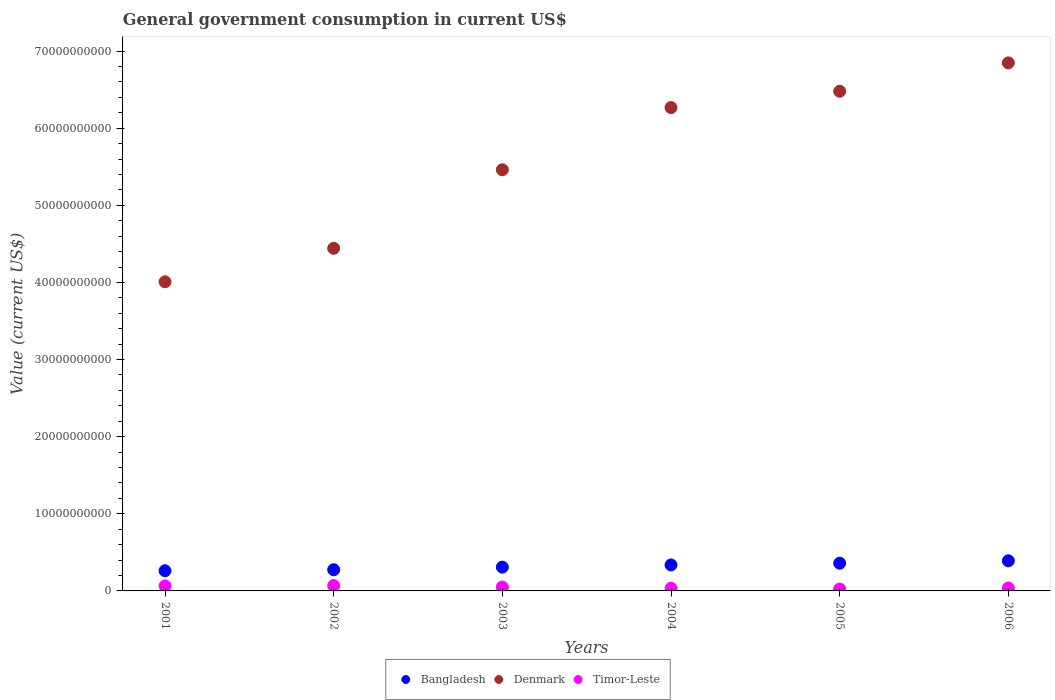How many different coloured dotlines are there?
Your response must be concise. 3. Is the number of dotlines equal to the number of legend labels?
Your response must be concise. Yes. What is the government conusmption in Bangladesh in 2003?
Give a very brief answer. 3.09e+09. Across all years, what is the maximum government conusmption in Denmark?
Your answer should be compact. 6.85e+1. Across all years, what is the minimum government conusmption in Denmark?
Your answer should be compact. 4.01e+1. In which year was the government conusmption in Bangladesh minimum?
Offer a terse response. 2001. What is the total government conusmption in Bangladesh in the graph?
Your answer should be very brief. 1.93e+1. What is the difference between the government conusmption in Timor-Leste in 2001 and that in 2004?
Provide a short and direct response. 3.05e+08. What is the difference between the government conusmption in Bangladesh in 2004 and the government conusmption in Denmark in 2002?
Provide a succinct answer. -4.11e+1. What is the average government conusmption in Bangladesh per year?
Provide a short and direct response. 3.22e+09. In the year 2004, what is the difference between the government conusmption in Bangladesh and government conusmption in Denmark?
Provide a succinct answer. -5.93e+1. What is the ratio of the government conusmption in Bangladesh in 2003 to that in 2004?
Ensure brevity in your answer.  0.92. Is the government conusmption in Bangladesh in 2001 less than that in 2005?
Your answer should be compact. Yes. Is the difference between the government conusmption in Bangladesh in 2002 and 2003 greater than the difference between the government conusmption in Denmark in 2002 and 2003?
Ensure brevity in your answer.  Yes. What is the difference between the highest and the second highest government conusmption in Denmark?
Keep it short and to the point. 3.68e+09. What is the difference between the highest and the lowest government conusmption in Bangladesh?
Offer a very short reply. 1.29e+09. In how many years, is the government conusmption in Denmark greater than the average government conusmption in Denmark taken over all years?
Provide a short and direct response. 3. Is it the case that in every year, the sum of the government conusmption in Timor-Leste and government conusmption in Denmark  is greater than the government conusmption in Bangladesh?
Provide a succinct answer. Yes. Are the values on the major ticks of Y-axis written in scientific E-notation?
Offer a terse response. No. Does the graph contain any zero values?
Provide a short and direct response. No. Does the graph contain grids?
Your answer should be compact. No. What is the title of the graph?
Provide a short and direct response. General government consumption in current US$. What is the label or title of the Y-axis?
Make the answer very short. Value (current US$). What is the Value (current US$) in Bangladesh in 2001?
Provide a succinct answer. 2.62e+09. What is the Value (current US$) in Denmark in 2001?
Provide a succinct answer. 4.01e+1. What is the Value (current US$) of Timor-Leste in 2001?
Offer a terse response. 6.52e+08. What is the Value (current US$) of Bangladesh in 2002?
Give a very brief answer. 2.75e+09. What is the Value (current US$) of Denmark in 2002?
Give a very brief answer. 4.44e+1. What is the Value (current US$) in Timor-Leste in 2002?
Your answer should be very brief. 6.95e+08. What is the Value (current US$) in Bangladesh in 2003?
Offer a terse response. 3.09e+09. What is the Value (current US$) in Denmark in 2003?
Your response must be concise. 5.46e+1. What is the Value (current US$) in Timor-Leste in 2003?
Your answer should be compact. 5.03e+08. What is the Value (current US$) of Bangladesh in 2004?
Offer a very short reply. 3.37e+09. What is the Value (current US$) in Denmark in 2004?
Provide a succinct answer. 6.27e+1. What is the Value (current US$) of Timor-Leste in 2004?
Give a very brief answer. 3.47e+08. What is the Value (current US$) of Bangladesh in 2005?
Provide a short and direct response. 3.60e+09. What is the Value (current US$) in Denmark in 2005?
Your response must be concise. 6.48e+1. What is the Value (current US$) in Timor-Leste in 2005?
Make the answer very short. 2.47e+08. What is the Value (current US$) of Bangladesh in 2006?
Give a very brief answer. 3.91e+09. What is the Value (current US$) in Denmark in 2006?
Offer a very short reply. 6.85e+1. What is the Value (current US$) in Timor-Leste in 2006?
Your response must be concise. 3.78e+08. Across all years, what is the maximum Value (current US$) of Bangladesh?
Provide a succinct answer. 3.91e+09. Across all years, what is the maximum Value (current US$) of Denmark?
Make the answer very short. 6.85e+1. Across all years, what is the maximum Value (current US$) in Timor-Leste?
Your answer should be very brief. 6.95e+08. Across all years, what is the minimum Value (current US$) of Bangladesh?
Keep it short and to the point. 2.62e+09. Across all years, what is the minimum Value (current US$) in Denmark?
Provide a short and direct response. 4.01e+1. Across all years, what is the minimum Value (current US$) in Timor-Leste?
Offer a terse response. 2.47e+08. What is the total Value (current US$) of Bangladesh in the graph?
Offer a very short reply. 1.93e+1. What is the total Value (current US$) in Denmark in the graph?
Give a very brief answer. 3.35e+11. What is the total Value (current US$) in Timor-Leste in the graph?
Ensure brevity in your answer.  2.82e+09. What is the difference between the Value (current US$) in Bangladesh in 2001 and that in 2002?
Keep it short and to the point. -1.32e+08. What is the difference between the Value (current US$) in Denmark in 2001 and that in 2002?
Provide a succinct answer. -4.34e+09. What is the difference between the Value (current US$) of Timor-Leste in 2001 and that in 2002?
Ensure brevity in your answer.  -4.30e+07. What is the difference between the Value (current US$) in Bangladesh in 2001 and that in 2003?
Keep it short and to the point. -4.69e+08. What is the difference between the Value (current US$) of Denmark in 2001 and that in 2003?
Your response must be concise. -1.45e+1. What is the difference between the Value (current US$) in Timor-Leste in 2001 and that in 2003?
Provide a succinct answer. 1.49e+08. What is the difference between the Value (current US$) of Bangladesh in 2001 and that in 2004?
Your answer should be very brief. -7.53e+08. What is the difference between the Value (current US$) in Denmark in 2001 and that in 2004?
Provide a short and direct response. -2.26e+1. What is the difference between the Value (current US$) in Timor-Leste in 2001 and that in 2004?
Offer a very short reply. 3.05e+08. What is the difference between the Value (current US$) of Bangladesh in 2001 and that in 2005?
Offer a terse response. -9.81e+08. What is the difference between the Value (current US$) in Denmark in 2001 and that in 2005?
Offer a terse response. -2.47e+1. What is the difference between the Value (current US$) in Timor-Leste in 2001 and that in 2005?
Your answer should be very brief. 4.05e+08. What is the difference between the Value (current US$) in Bangladesh in 2001 and that in 2006?
Keep it short and to the point. -1.29e+09. What is the difference between the Value (current US$) of Denmark in 2001 and that in 2006?
Provide a succinct answer. -2.84e+1. What is the difference between the Value (current US$) in Timor-Leste in 2001 and that in 2006?
Ensure brevity in your answer.  2.74e+08. What is the difference between the Value (current US$) of Bangladesh in 2002 and that in 2003?
Offer a terse response. -3.37e+08. What is the difference between the Value (current US$) of Denmark in 2002 and that in 2003?
Offer a very short reply. -1.02e+1. What is the difference between the Value (current US$) in Timor-Leste in 2002 and that in 2003?
Ensure brevity in your answer.  1.92e+08. What is the difference between the Value (current US$) of Bangladesh in 2002 and that in 2004?
Provide a succinct answer. -6.20e+08. What is the difference between the Value (current US$) of Denmark in 2002 and that in 2004?
Your answer should be very brief. -1.83e+1. What is the difference between the Value (current US$) in Timor-Leste in 2002 and that in 2004?
Make the answer very short. 3.48e+08. What is the difference between the Value (current US$) of Bangladesh in 2002 and that in 2005?
Offer a terse response. -8.49e+08. What is the difference between the Value (current US$) of Denmark in 2002 and that in 2005?
Provide a succinct answer. -2.04e+1. What is the difference between the Value (current US$) in Timor-Leste in 2002 and that in 2005?
Your answer should be compact. 4.48e+08. What is the difference between the Value (current US$) in Bangladesh in 2002 and that in 2006?
Keep it short and to the point. -1.16e+09. What is the difference between the Value (current US$) of Denmark in 2002 and that in 2006?
Give a very brief answer. -2.40e+1. What is the difference between the Value (current US$) in Timor-Leste in 2002 and that in 2006?
Provide a short and direct response. 3.17e+08. What is the difference between the Value (current US$) of Bangladesh in 2003 and that in 2004?
Give a very brief answer. -2.84e+08. What is the difference between the Value (current US$) of Denmark in 2003 and that in 2004?
Your answer should be compact. -8.07e+09. What is the difference between the Value (current US$) of Timor-Leste in 2003 and that in 2004?
Give a very brief answer. 1.56e+08. What is the difference between the Value (current US$) in Bangladesh in 2003 and that in 2005?
Keep it short and to the point. -5.12e+08. What is the difference between the Value (current US$) in Denmark in 2003 and that in 2005?
Your answer should be compact. -1.02e+1. What is the difference between the Value (current US$) of Timor-Leste in 2003 and that in 2005?
Make the answer very short. 2.56e+08. What is the difference between the Value (current US$) in Bangladesh in 2003 and that in 2006?
Make the answer very short. -8.22e+08. What is the difference between the Value (current US$) in Denmark in 2003 and that in 2006?
Provide a succinct answer. -1.39e+1. What is the difference between the Value (current US$) in Timor-Leste in 2003 and that in 2006?
Your response must be concise. 1.25e+08. What is the difference between the Value (current US$) of Bangladesh in 2004 and that in 2005?
Your response must be concise. -2.28e+08. What is the difference between the Value (current US$) in Denmark in 2004 and that in 2005?
Ensure brevity in your answer.  -2.11e+09. What is the difference between the Value (current US$) of Bangladesh in 2004 and that in 2006?
Keep it short and to the point. -5.38e+08. What is the difference between the Value (current US$) of Denmark in 2004 and that in 2006?
Your answer should be compact. -5.79e+09. What is the difference between the Value (current US$) in Timor-Leste in 2004 and that in 2006?
Give a very brief answer. -3.10e+07. What is the difference between the Value (current US$) in Bangladesh in 2005 and that in 2006?
Give a very brief answer. -3.10e+08. What is the difference between the Value (current US$) in Denmark in 2005 and that in 2006?
Offer a terse response. -3.68e+09. What is the difference between the Value (current US$) of Timor-Leste in 2005 and that in 2006?
Your answer should be compact. -1.31e+08. What is the difference between the Value (current US$) of Bangladesh in 2001 and the Value (current US$) of Denmark in 2002?
Offer a terse response. -4.18e+1. What is the difference between the Value (current US$) of Bangladesh in 2001 and the Value (current US$) of Timor-Leste in 2002?
Make the answer very short. 1.92e+09. What is the difference between the Value (current US$) of Denmark in 2001 and the Value (current US$) of Timor-Leste in 2002?
Provide a short and direct response. 3.94e+1. What is the difference between the Value (current US$) of Bangladesh in 2001 and the Value (current US$) of Denmark in 2003?
Make the answer very short. -5.20e+1. What is the difference between the Value (current US$) of Bangladesh in 2001 and the Value (current US$) of Timor-Leste in 2003?
Ensure brevity in your answer.  2.11e+09. What is the difference between the Value (current US$) of Denmark in 2001 and the Value (current US$) of Timor-Leste in 2003?
Give a very brief answer. 3.96e+1. What is the difference between the Value (current US$) of Bangladesh in 2001 and the Value (current US$) of Denmark in 2004?
Your response must be concise. -6.01e+1. What is the difference between the Value (current US$) in Bangladesh in 2001 and the Value (current US$) in Timor-Leste in 2004?
Provide a succinct answer. 2.27e+09. What is the difference between the Value (current US$) of Denmark in 2001 and the Value (current US$) of Timor-Leste in 2004?
Provide a succinct answer. 3.97e+1. What is the difference between the Value (current US$) in Bangladesh in 2001 and the Value (current US$) in Denmark in 2005?
Offer a very short reply. -6.22e+1. What is the difference between the Value (current US$) of Bangladesh in 2001 and the Value (current US$) of Timor-Leste in 2005?
Offer a terse response. 2.37e+09. What is the difference between the Value (current US$) in Denmark in 2001 and the Value (current US$) in Timor-Leste in 2005?
Provide a short and direct response. 3.98e+1. What is the difference between the Value (current US$) in Bangladesh in 2001 and the Value (current US$) in Denmark in 2006?
Make the answer very short. -6.59e+1. What is the difference between the Value (current US$) of Bangladesh in 2001 and the Value (current US$) of Timor-Leste in 2006?
Ensure brevity in your answer.  2.24e+09. What is the difference between the Value (current US$) in Denmark in 2001 and the Value (current US$) in Timor-Leste in 2006?
Provide a succinct answer. 3.97e+1. What is the difference between the Value (current US$) in Bangladesh in 2002 and the Value (current US$) in Denmark in 2003?
Provide a succinct answer. -5.19e+1. What is the difference between the Value (current US$) in Bangladesh in 2002 and the Value (current US$) in Timor-Leste in 2003?
Offer a very short reply. 2.25e+09. What is the difference between the Value (current US$) of Denmark in 2002 and the Value (current US$) of Timor-Leste in 2003?
Offer a very short reply. 4.39e+1. What is the difference between the Value (current US$) in Bangladesh in 2002 and the Value (current US$) in Denmark in 2004?
Your response must be concise. -5.99e+1. What is the difference between the Value (current US$) of Bangladesh in 2002 and the Value (current US$) of Timor-Leste in 2004?
Give a very brief answer. 2.40e+09. What is the difference between the Value (current US$) of Denmark in 2002 and the Value (current US$) of Timor-Leste in 2004?
Make the answer very short. 4.41e+1. What is the difference between the Value (current US$) in Bangladesh in 2002 and the Value (current US$) in Denmark in 2005?
Offer a very short reply. -6.20e+1. What is the difference between the Value (current US$) in Bangladesh in 2002 and the Value (current US$) in Timor-Leste in 2005?
Your answer should be compact. 2.50e+09. What is the difference between the Value (current US$) of Denmark in 2002 and the Value (current US$) of Timor-Leste in 2005?
Your answer should be very brief. 4.42e+1. What is the difference between the Value (current US$) of Bangladesh in 2002 and the Value (current US$) of Denmark in 2006?
Provide a succinct answer. -6.57e+1. What is the difference between the Value (current US$) of Bangladesh in 2002 and the Value (current US$) of Timor-Leste in 2006?
Ensure brevity in your answer.  2.37e+09. What is the difference between the Value (current US$) of Denmark in 2002 and the Value (current US$) of Timor-Leste in 2006?
Your response must be concise. 4.40e+1. What is the difference between the Value (current US$) of Bangladesh in 2003 and the Value (current US$) of Denmark in 2004?
Give a very brief answer. -5.96e+1. What is the difference between the Value (current US$) in Bangladesh in 2003 and the Value (current US$) in Timor-Leste in 2004?
Give a very brief answer. 2.74e+09. What is the difference between the Value (current US$) of Denmark in 2003 and the Value (current US$) of Timor-Leste in 2004?
Offer a very short reply. 5.43e+1. What is the difference between the Value (current US$) of Bangladesh in 2003 and the Value (current US$) of Denmark in 2005?
Your answer should be compact. -6.17e+1. What is the difference between the Value (current US$) in Bangladesh in 2003 and the Value (current US$) in Timor-Leste in 2005?
Offer a terse response. 2.84e+09. What is the difference between the Value (current US$) in Denmark in 2003 and the Value (current US$) in Timor-Leste in 2005?
Provide a short and direct response. 5.44e+1. What is the difference between the Value (current US$) of Bangladesh in 2003 and the Value (current US$) of Denmark in 2006?
Offer a very short reply. -6.54e+1. What is the difference between the Value (current US$) in Bangladesh in 2003 and the Value (current US$) in Timor-Leste in 2006?
Offer a very short reply. 2.71e+09. What is the difference between the Value (current US$) in Denmark in 2003 and the Value (current US$) in Timor-Leste in 2006?
Your response must be concise. 5.42e+1. What is the difference between the Value (current US$) of Bangladesh in 2004 and the Value (current US$) of Denmark in 2005?
Your response must be concise. -6.14e+1. What is the difference between the Value (current US$) of Bangladesh in 2004 and the Value (current US$) of Timor-Leste in 2005?
Give a very brief answer. 3.12e+09. What is the difference between the Value (current US$) of Denmark in 2004 and the Value (current US$) of Timor-Leste in 2005?
Provide a short and direct response. 6.24e+1. What is the difference between the Value (current US$) of Bangladesh in 2004 and the Value (current US$) of Denmark in 2006?
Your answer should be compact. -6.51e+1. What is the difference between the Value (current US$) in Bangladesh in 2004 and the Value (current US$) in Timor-Leste in 2006?
Make the answer very short. 2.99e+09. What is the difference between the Value (current US$) of Denmark in 2004 and the Value (current US$) of Timor-Leste in 2006?
Offer a terse response. 6.23e+1. What is the difference between the Value (current US$) in Bangladesh in 2005 and the Value (current US$) in Denmark in 2006?
Give a very brief answer. -6.49e+1. What is the difference between the Value (current US$) in Bangladesh in 2005 and the Value (current US$) in Timor-Leste in 2006?
Your response must be concise. 3.22e+09. What is the difference between the Value (current US$) of Denmark in 2005 and the Value (current US$) of Timor-Leste in 2006?
Give a very brief answer. 6.44e+1. What is the average Value (current US$) of Bangladesh per year?
Offer a very short reply. 3.22e+09. What is the average Value (current US$) of Denmark per year?
Make the answer very short. 5.58e+1. What is the average Value (current US$) of Timor-Leste per year?
Provide a short and direct response. 4.70e+08. In the year 2001, what is the difference between the Value (current US$) of Bangladesh and Value (current US$) of Denmark?
Offer a very short reply. -3.75e+1. In the year 2001, what is the difference between the Value (current US$) of Bangladesh and Value (current US$) of Timor-Leste?
Your response must be concise. 1.96e+09. In the year 2001, what is the difference between the Value (current US$) of Denmark and Value (current US$) of Timor-Leste?
Your response must be concise. 3.94e+1. In the year 2002, what is the difference between the Value (current US$) in Bangladesh and Value (current US$) in Denmark?
Your response must be concise. -4.17e+1. In the year 2002, what is the difference between the Value (current US$) in Bangladesh and Value (current US$) in Timor-Leste?
Make the answer very short. 2.05e+09. In the year 2002, what is the difference between the Value (current US$) in Denmark and Value (current US$) in Timor-Leste?
Ensure brevity in your answer.  4.37e+1. In the year 2003, what is the difference between the Value (current US$) of Bangladesh and Value (current US$) of Denmark?
Your answer should be compact. -5.15e+1. In the year 2003, what is the difference between the Value (current US$) of Bangladesh and Value (current US$) of Timor-Leste?
Make the answer very short. 2.58e+09. In the year 2003, what is the difference between the Value (current US$) of Denmark and Value (current US$) of Timor-Leste?
Your answer should be compact. 5.41e+1. In the year 2004, what is the difference between the Value (current US$) in Bangladesh and Value (current US$) in Denmark?
Your response must be concise. -5.93e+1. In the year 2004, what is the difference between the Value (current US$) of Bangladesh and Value (current US$) of Timor-Leste?
Your response must be concise. 3.02e+09. In the year 2004, what is the difference between the Value (current US$) in Denmark and Value (current US$) in Timor-Leste?
Make the answer very short. 6.23e+1. In the year 2005, what is the difference between the Value (current US$) in Bangladesh and Value (current US$) in Denmark?
Provide a succinct answer. -6.12e+1. In the year 2005, what is the difference between the Value (current US$) of Bangladesh and Value (current US$) of Timor-Leste?
Your response must be concise. 3.35e+09. In the year 2005, what is the difference between the Value (current US$) in Denmark and Value (current US$) in Timor-Leste?
Ensure brevity in your answer.  6.45e+1. In the year 2006, what is the difference between the Value (current US$) of Bangladesh and Value (current US$) of Denmark?
Ensure brevity in your answer.  -6.46e+1. In the year 2006, what is the difference between the Value (current US$) in Bangladesh and Value (current US$) in Timor-Leste?
Your response must be concise. 3.53e+09. In the year 2006, what is the difference between the Value (current US$) in Denmark and Value (current US$) in Timor-Leste?
Your response must be concise. 6.81e+1. What is the ratio of the Value (current US$) in Bangladesh in 2001 to that in 2002?
Give a very brief answer. 0.95. What is the ratio of the Value (current US$) of Denmark in 2001 to that in 2002?
Ensure brevity in your answer.  0.9. What is the ratio of the Value (current US$) of Timor-Leste in 2001 to that in 2002?
Give a very brief answer. 0.94. What is the ratio of the Value (current US$) of Bangladesh in 2001 to that in 2003?
Your response must be concise. 0.85. What is the ratio of the Value (current US$) in Denmark in 2001 to that in 2003?
Your answer should be very brief. 0.73. What is the ratio of the Value (current US$) of Timor-Leste in 2001 to that in 2003?
Your answer should be very brief. 1.3. What is the ratio of the Value (current US$) in Bangladesh in 2001 to that in 2004?
Provide a succinct answer. 0.78. What is the ratio of the Value (current US$) of Denmark in 2001 to that in 2004?
Your answer should be compact. 0.64. What is the ratio of the Value (current US$) of Timor-Leste in 2001 to that in 2004?
Ensure brevity in your answer.  1.88. What is the ratio of the Value (current US$) in Bangladesh in 2001 to that in 2005?
Offer a terse response. 0.73. What is the ratio of the Value (current US$) in Denmark in 2001 to that in 2005?
Ensure brevity in your answer.  0.62. What is the ratio of the Value (current US$) in Timor-Leste in 2001 to that in 2005?
Offer a terse response. 2.64. What is the ratio of the Value (current US$) in Bangladesh in 2001 to that in 2006?
Your answer should be very brief. 0.67. What is the ratio of the Value (current US$) of Denmark in 2001 to that in 2006?
Ensure brevity in your answer.  0.59. What is the ratio of the Value (current US$) in Timor-Leste in 2001 to that in 2006?
Keep it short and to the point. 1.72. What is the ratio of the Value (current US$) in Bangladesh in 2002 to that in 2003?
Ensure brevity in your answer.  0.89. What is the ratio of the Value (current US$) in Denmark in 2002 to that in 2003?
Keep it short and to the point. 0.81. What is the ratio of the Value (current US$) of Timor-Leste in 2002 to that in 2003?
Offer a very short reply. 1.38. What is the ratio of the Value (current US$) in Bangladesh in 2002 to that in 2004?
Ensure brevity in your answer.  0.82. What is the ratio of the Value (current US$) of Denmark in 2002 to that in 2004?
Provide a short and direct response. 0.71. What is the ratio of the Value (current US$) of Timor-Leste in 2002 to that in 2004?
Your answer should be very brief. 2. What is the ratio of the Value (current US$) of Bangladesh in 2002 to that in 2005?
Give a very brief answer. 0.76. What is the ratio of the Value (current US$) in Denmark in 2002 to that in 2005?
Give a very brief answer. 0.69. What is the ratio of the Value (current US$) of Timor-Leste in 2002 to that in 2005?
Provide a short and direct response. 2.81. What is the ratio of the Value (current US$) in Bangladesh in 2002 to that in 2006?
Offer a very short reply. 0.7. What is the ratio of the Value (current US$) in Denmark in 2002 to that in 2006?
Your answer should be very brief. 0.65. What is the ratio of the Value (current US$) in Timor-Leste in 2002 to that in 2006?
Your response must be concise. 1.84. What is the ratio of the Value (current US$) in Bangladesh in 2003 to that in 2004?
Your response must be concise. 0.92. What is the ratio of the Value (current US$) of Denmark in 2003 to that in 2004?
Your response must be concise. 0.87. What is the ratio of the Value (current US$) in Timor-Leste in 2003 to that in 2004?
Give a very brief answer. 1.45. What is the ratio of the Value (current US$) of Bangladesh in 2003 to that in 2005?
Ensure brevity in your answer.  0.86. What is the ratio of the Value (current US$) of Denmark in 2003 to that in 2005?
Provide a short and direct response. 0.84. What is the ratio of the Value (current US$) of Timor-Leste in 2003 to that in 2005?
Offer a very short reply. 2.04. What is the ratio of the Value (current US$) of Bangladesh in 2003 to that in 2006?
Make the answer very short. 0.79. What is the ratio of the Value (current US$) in Denmark in 2003 to that in 2006?
Offer a very short reply. 0.8. What is the ratio of the Value (current US$) of Timor-Leste in 2003 to that in 2006?
Ensure brevity in your answer.  1.33. What is the ratio of the Value (current US$) of Bangladesh in 2004 to that in 2005?
Keep it short and to the point. 0.94. What is the ratio of the Value (current US$) of Denmark in 2004 to that in 2005?
Your answer should be compact. 0.97. What is the ratio of the Value (current US$) of Timor-Leste in 2004 to that in 2005?
Offer a very short reply. 1.4. What is the ratio of the Value (current US$) in Bangladesh in 2004 to that in 2006?
Give a very brief answer. 0.86. What is the ratio of the Value (current US$) in Denmark in 2004 to that in 2006?
Make the answer very short. 0.92. What is the ratio of the Value (current US$) of Timor-Leste in 2004 to that in 2006?
Keep it short and to the point. 0.92. What is the ratio of the Value (current US$) of Bangladesh in 2005 to that in 2006?
Keep it short and to the point. 0.92. What is the ratio of the Value (current US$) in Denmark in 2005 to that in 2006?
Your answer should be compact. 0.95. What is the ratio of the Value (current US$) in Timor-Leste in 2005 to that in 2006?
Make the answer very short. 0.65. What is the difference between the highest and the second highest Value (current US$) in Bangladesh?
Make the answer very short. 3.10e+08. What is the difference between the highest and the second highest Value (current US$) of Denmark?
Give a very brief answer. 3.68e+09. What is the difference between the highest and the second highest Value (current US$) of Timor-Leste?
Provide a short and direct response. 4.30e+07. What is the difference between the highest and the lowest Value (current US$) in Bangladesh?
Make the answer very short. 1.29e+09. What is the difference between the highest and the lowest Value (current US$) in Denmark?
Provide a succinct answer. 2.84e+1. What is the difference between the highest and the lowest Value (current US$) in Timor-Leste?
Your answer should be compact. 4.48e+08. 